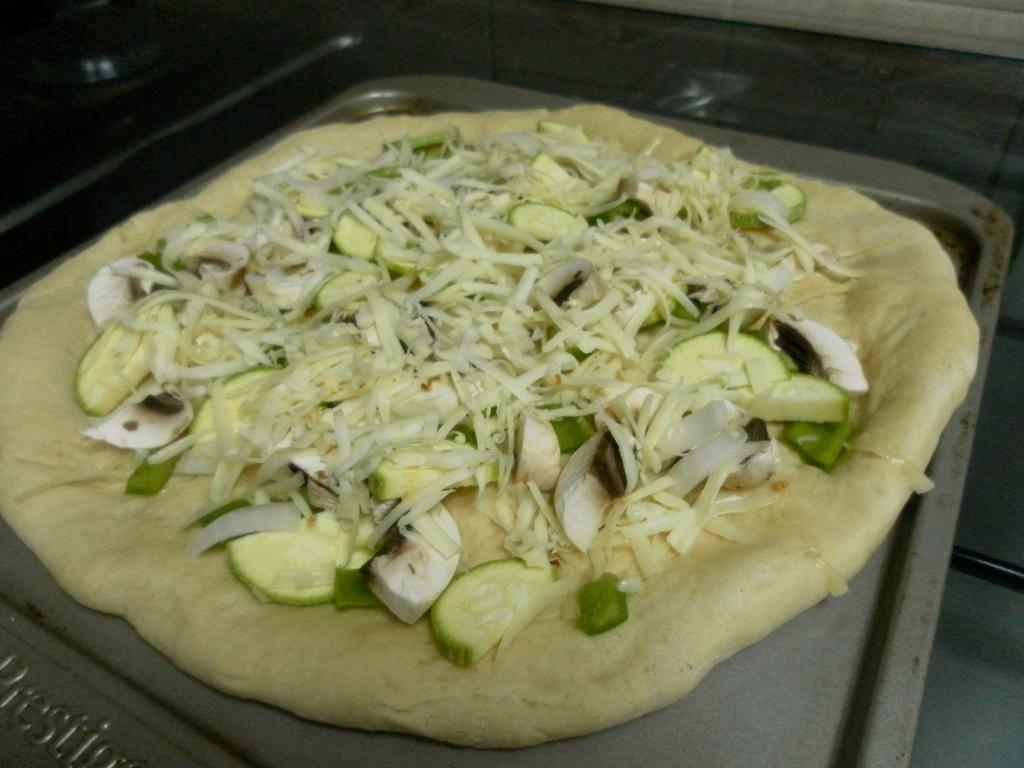What is located in the center of the image? There is a plate in the middle of the image. What is on the plate? The plate contains food. What type of railway can be seen in the image? There is no railway present in the image; it only contains a plate with food. 